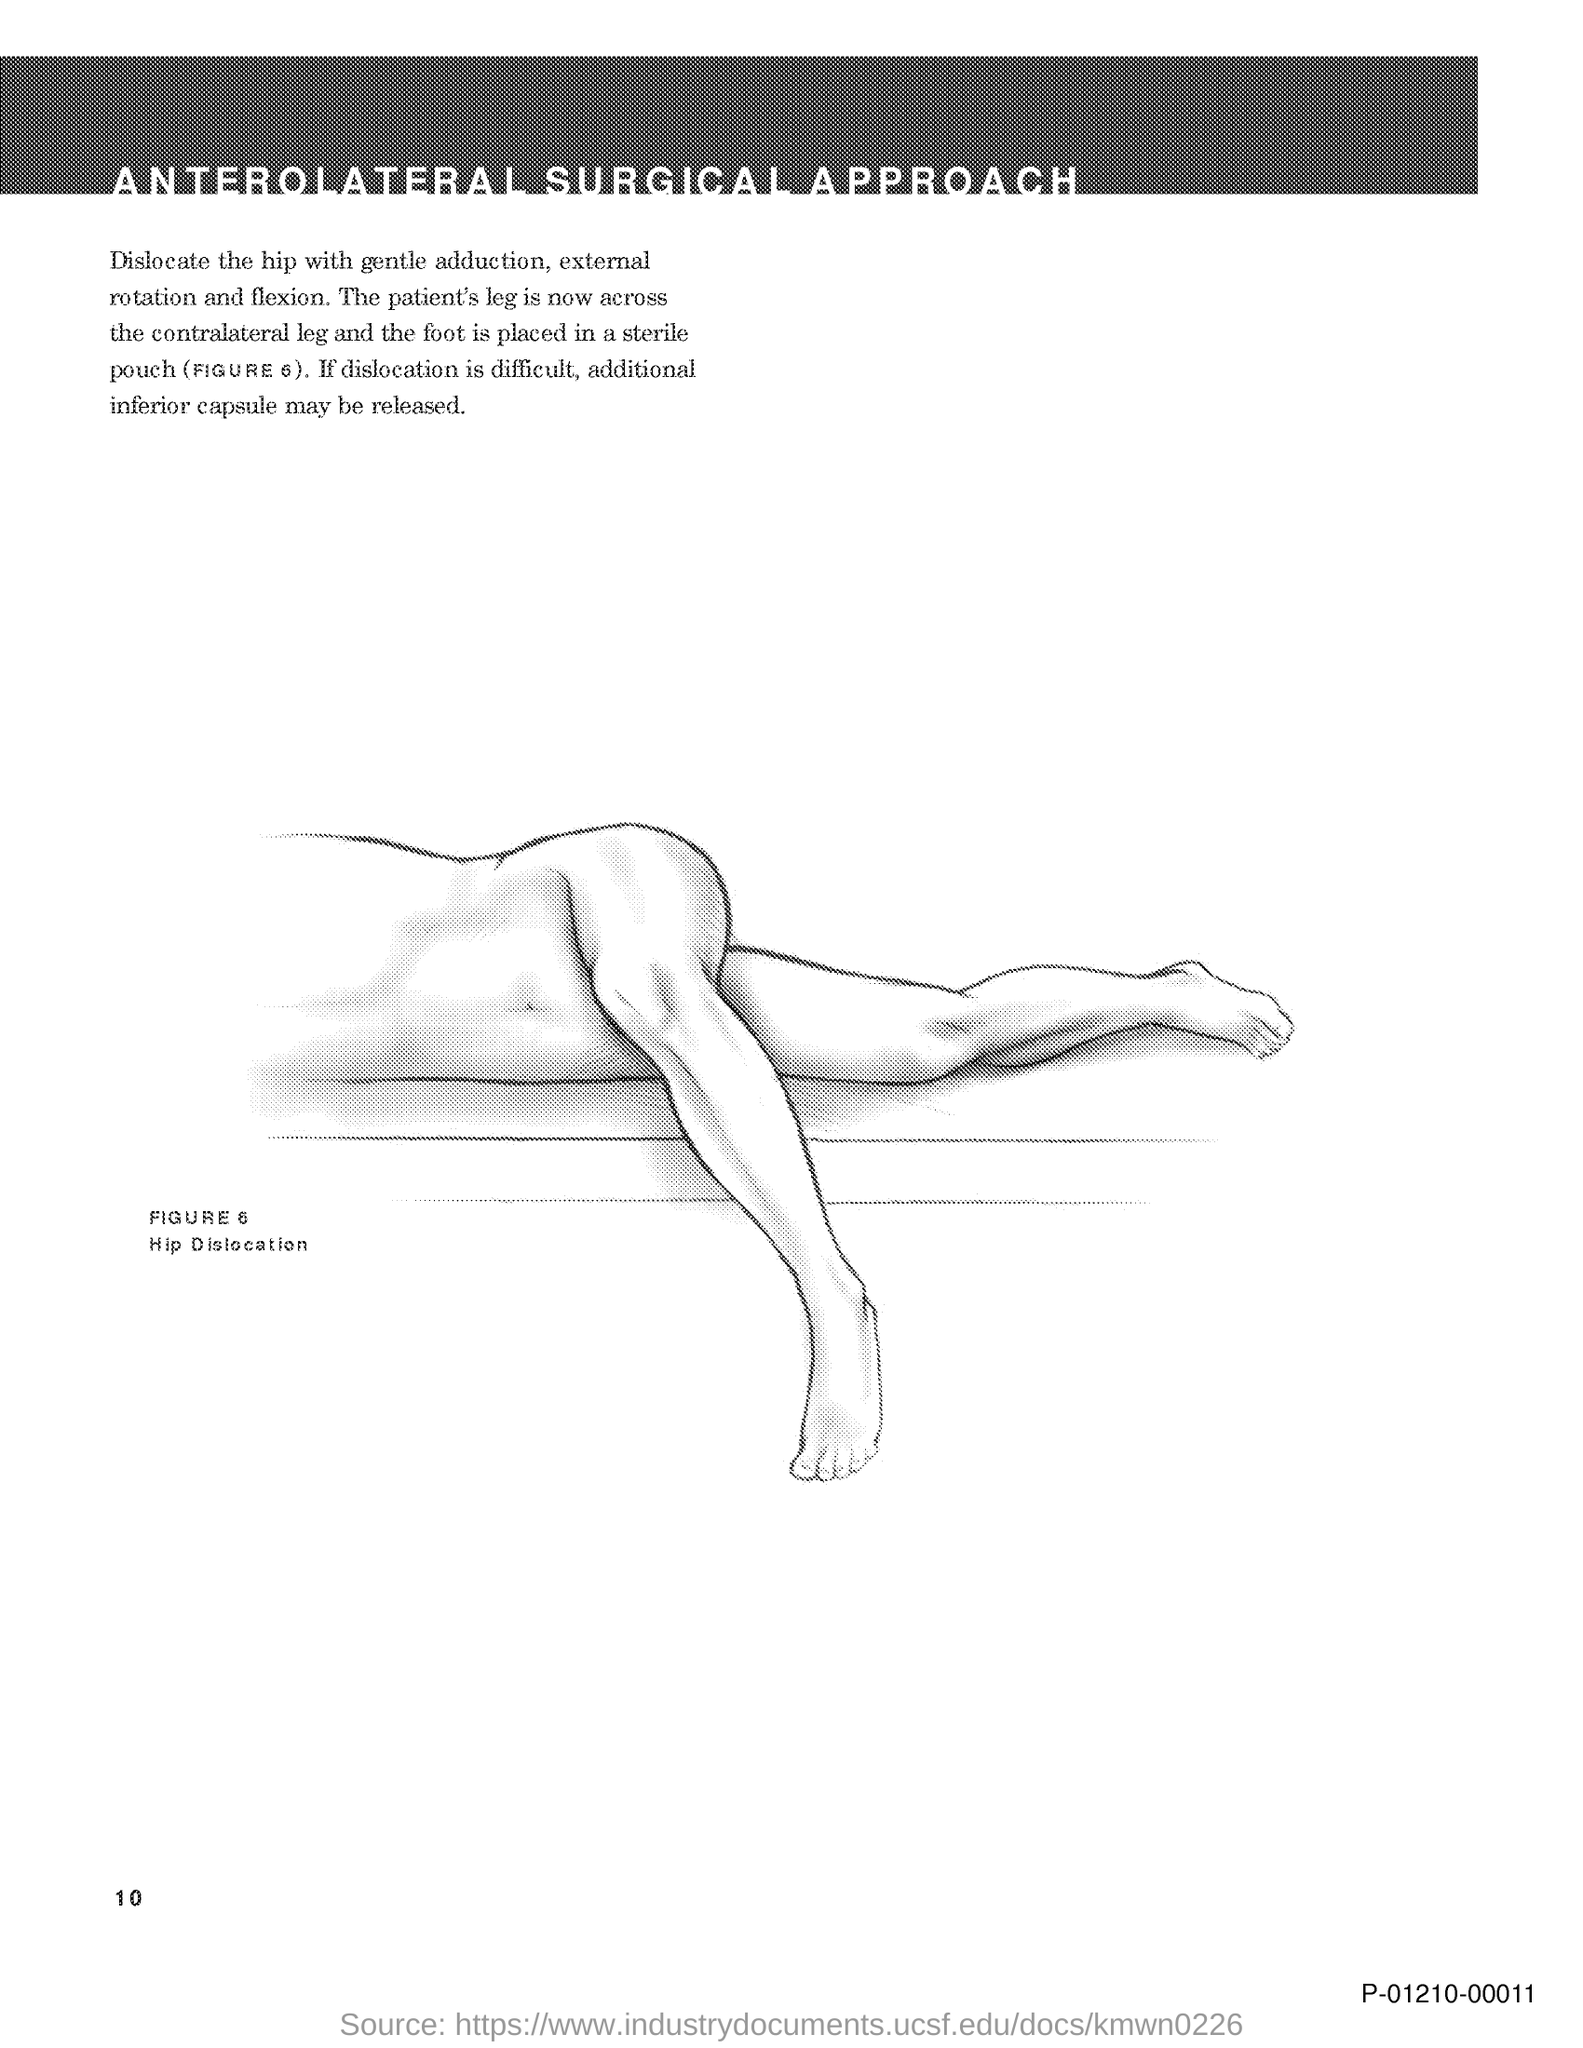List a handful of essential elements in this visual. FIGURE 6 depicts hip dislocation, which is a condition characterized by the displacement of the ball of the thigh bone from the socket of the hip joint. The document title is "ANTEROLATERAL SURGICAL APPROACH..". The document in question is page 10. 